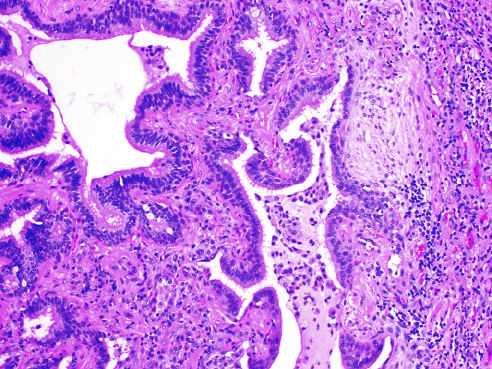where is honey-combing present to?
Answer the question using a single word or phrase. Left 